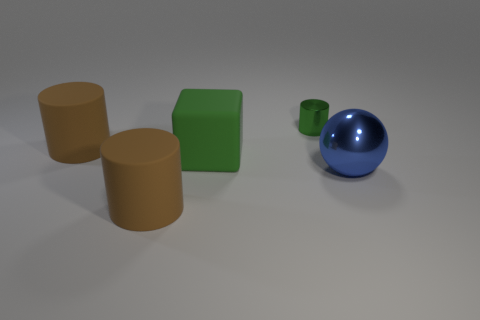Does the metallic object in front of the tiny green cylinder have the same color as the matte object behind the green matte block?
Make the answer very short. No. There is a large green matte object right of the brown matte thing that is in front of the big green rubber object in front of the green cylinder; what is its shape?
Your answer should be very brief. Cube. The thing that is right of the rubber block and in front of the small green object has what shape?
Ensure brevity in your answer.  Sphere. How many big metal things are behind the big brown cylinder that is behind the metal object in front of the small green metallic thing?
Ensure brevity in your answer.  0. Is there any other thing that has the same size as the green matte block?
Ensure brevity in your answer.  Yes. Does the green object in front of the tiny green cylinder have the same material as the tiny cylinder?
Offer a very short reply. No. What number of other objects are there of the same color as the big rubber block?
Ensure brevity in your answer.  1. There is a brown matte object that is behind the big blue metal ball; is its shape the same as the brown rubber thing that is in front of the large blue sphere?
Offer a very short reply. Yes. How many balls are either large blue objects or big green matte things?
Your answer should be compact. 1. Is the number of large shiny balls behind the big green rubber thing less than the number of blue matte cubes?
Make the answer very short. No. 